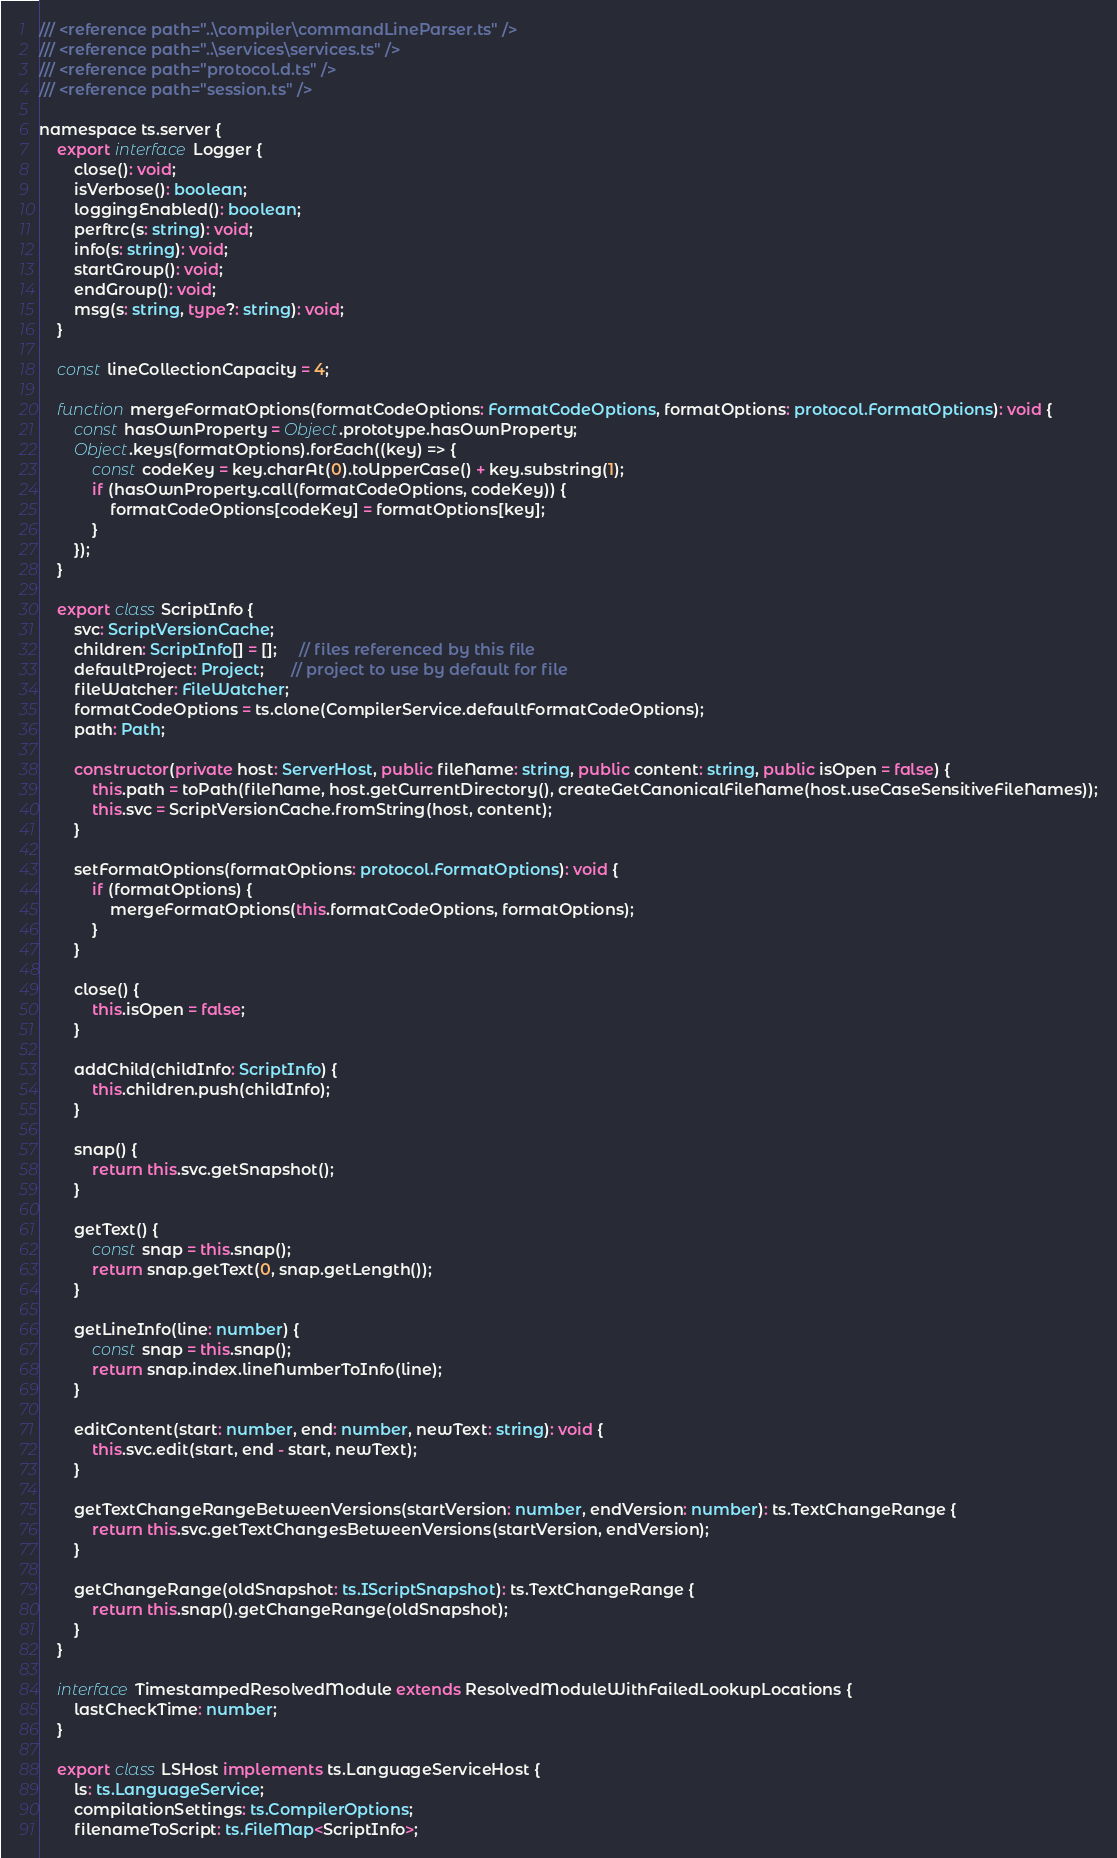Convert code to text. <code><loc_0><loc_0><loc_500><loc_500><_TypeScript_>/// <reference path="..\compiler\commandLineParser.ts" />
/// <reference path="..\services\services.ts" />
/// <reference path="protocol.d.ts" />
/// <reference path="session.ts" />

namespace ts.server {
    export interface Logger {
        close(): void;
        isVerbose(): boolean;
        loggingEnabled(): boolean;
        perftrc(s: string): void;
        info(s: string): void;
        startGroup(): void;
        endGroup(): void;
        msg(s: string, type?: string): void;
    }

    const lineCollectionCapacity = 4;

    function mergeFormatOptions(formatCodeOptions: FormatCodeOptions, formatOptions: protocol.FormatOptions): void {
        const hasOwnProperty = Object.prototype.hasOwnProperty;
        Object.keys(formatOptions).forEach((key) => {
            const codeKey = key.charAt(0).toUpperCase() + key.substring(1);
            if (hasOwnProperty.call(formatCodeOptions, codeKey)) {
                formatCodeOptions[codeKey] = formatOptions[key];
            }
        });
    }

    export class ScriptInfo {
        svc: ScriptVersionCache;
        children: ScriptInfo[] = [];     // files referenced by this file
        defaultProject: Project;      // project to use by default for file
        fileWatcher: FileWatcher;
        formatCodeOptions = ts.clone(CompilerService.defaultFormatCodeOptions);
        path: Path;

        constructor(private host: ServerHost, public fileName: string, public content: string, public isOpen = false) {
            this.path = toPath(fileName, host.getCurrentDirectory(), createGetCanonicalFileName(host.useCaseSensitiveFileNames));
            this.svc = ScriptVersionCache.fromString(host, content);
        }

        setFormatOptions(formatOptions: protocol.FormatOptions): void {
            if (formatOptions) {
                mergeFormatOptions(this.formatCodeOptions, formatOptions);
            }
        }

        close() {
            this.isOpen = false;
        }

        addChild(childInfo: ScriptInfo) {
            this.children.push(childInfo);
        }

        snap() {
            return this.svc.getSnapshot();
        }

        getText() {
            const snap = this.snap();
            return snap.getText(0, snap.getLength());
        }

        getLineInfo(line: number) {
            const snap = this.snap();
            return snap.index.lineNumberToInfo(line);
        }

        editContent(start: number, end: number, newText: string): void {
            this.svc.edit(start, end - start, newText);
        }

        getTextChangeRangeBetweenVersions(startVersion: number, endVersion: number): ts.TextChangeRange {
            return this.svc.getTextChangesBetweenVersions(startVersion, endVersion);
        }

        getChangeRange(oldSnapshot: ts.IScriptSnapshot): ts.TextChangeRange {
            return this.snap().getChangeRange(oldSnapshot);
        }
    }

    interface TimestampedResolvedModule extends ResolvedModuleWithFailedLookupLocations {
        lastCheckTime: number;
    }

    export class LSHost implements ts.LanguageServiceHost {
        ls: ts.LanguageService;
        compilationSettings: ts.CompilerOptions;
        filenameToScript: ts.FileMap<ScriptInfo>;</code> 